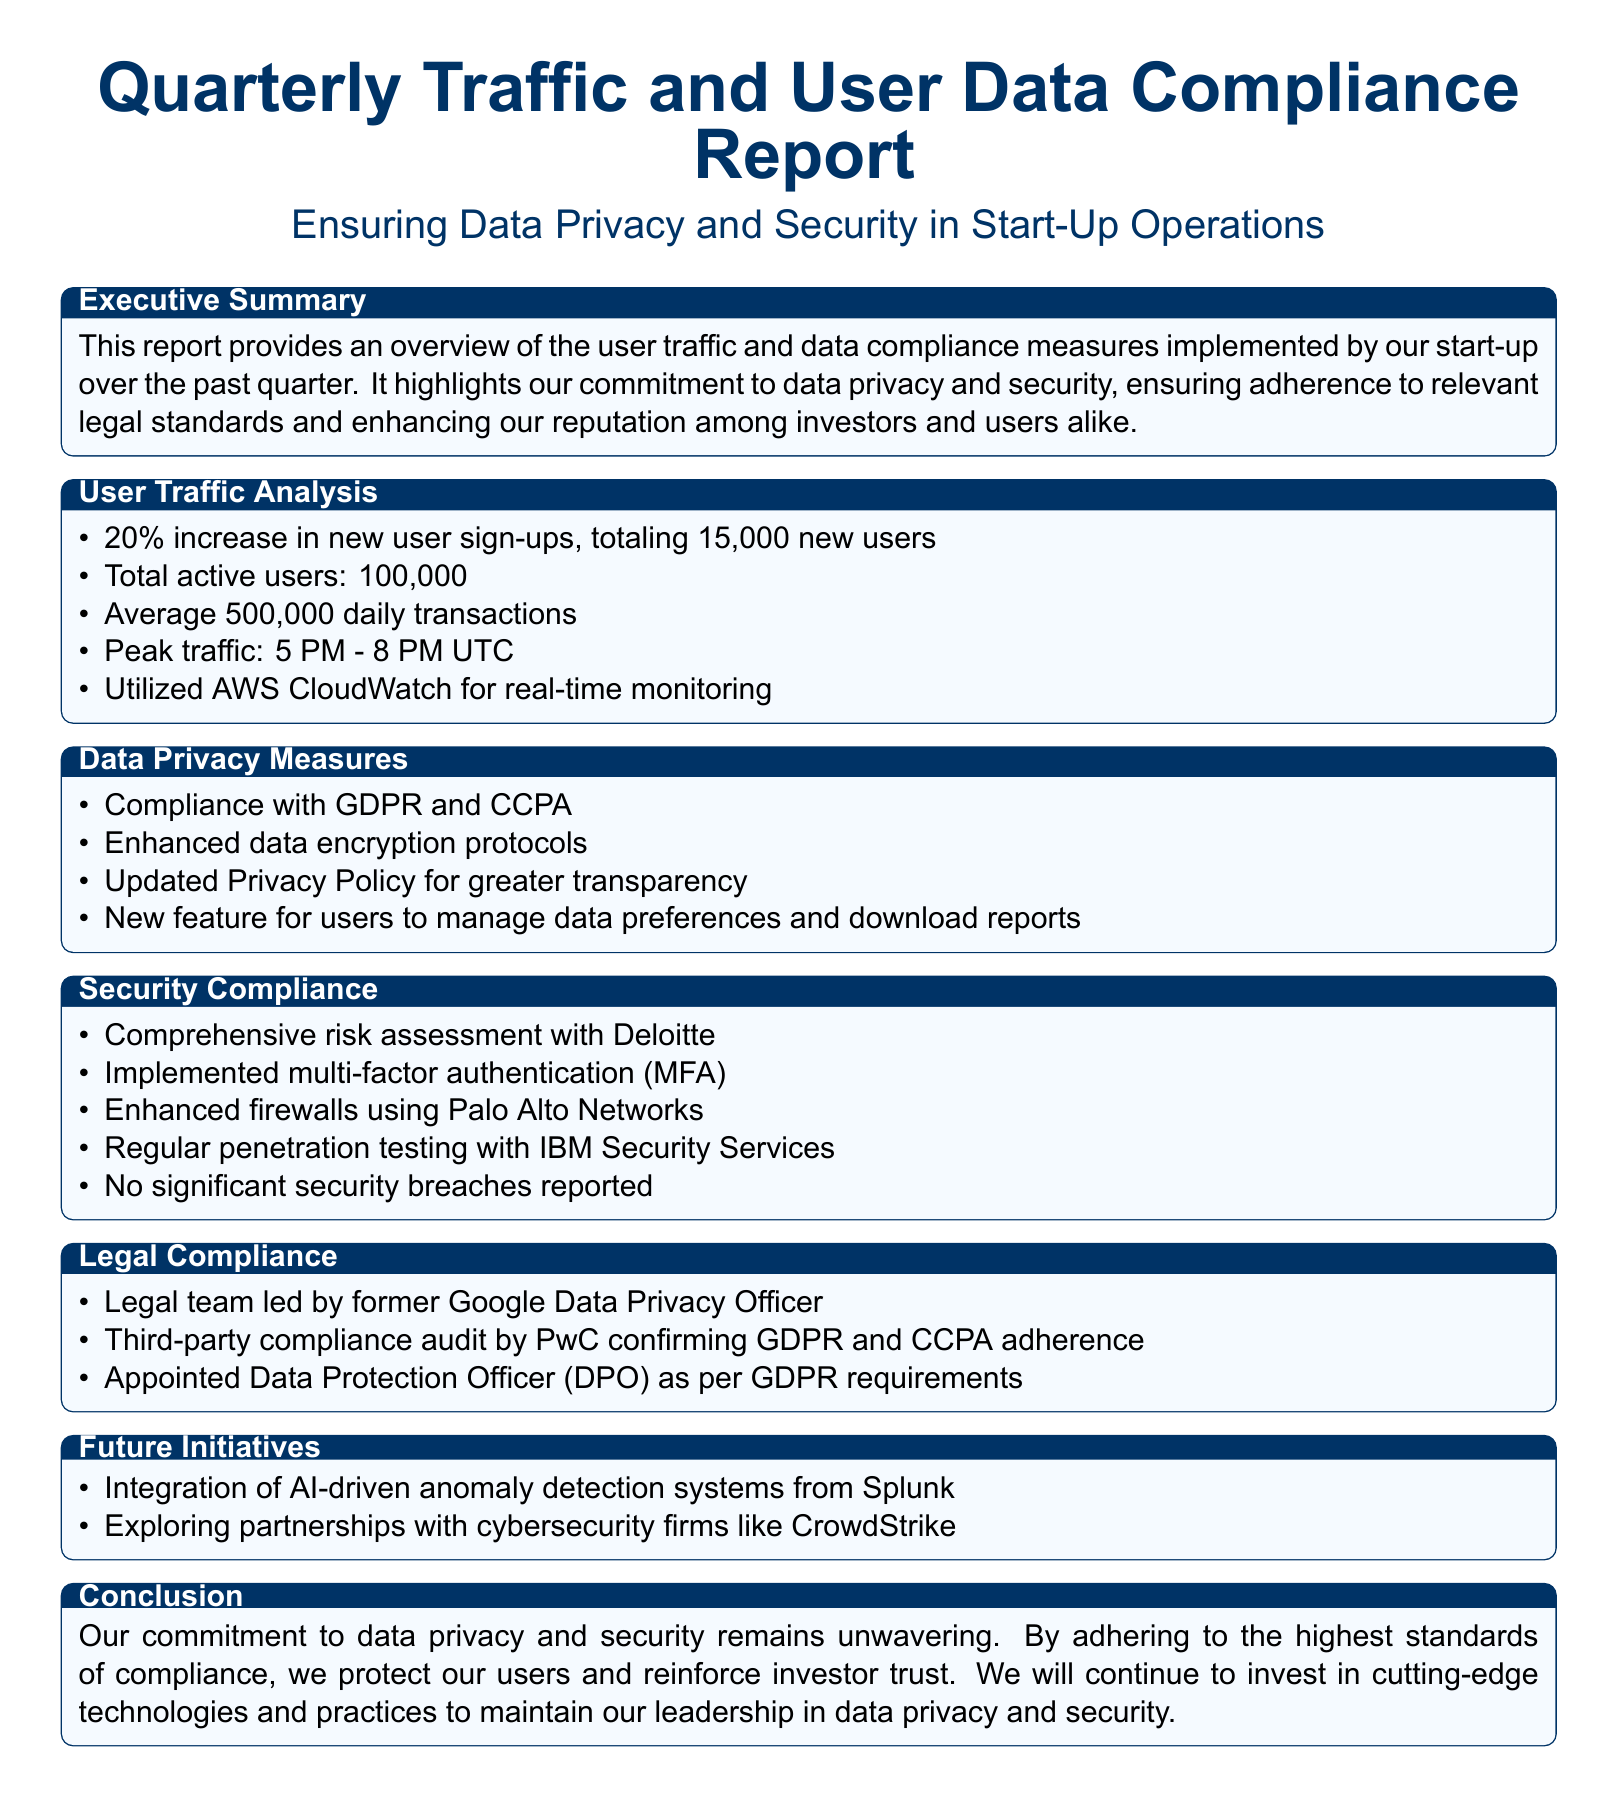What percentage increase in new user sign-ups was reported? The document states that there was a 20% increase in new user sign-ups, indicating growth in the user base.
Answer: 20% What is the total number of active users? The report mentions a total of 100,000 active users, reflecting the current user engagement level.
Answer: 100,000 Which data privacy regulations does the company comply with? The report lists GDPR and CCPA as the regulatory frameworks adhered to by the start-up, ensuring legal compliance.
Answer: GDPR and CCPA Who conducted the comprehensive risk assessment? The document identifies Deloitte as the firm responsible for performing the risk assessment, ensuring thorough evaluation of security measures.
Answer: Deloitte What feature was introduced for users regarding their data preferences? The report states that a new feature allows users to manage their data preferences and download reports, enhancing transparency.
Answer: Manage data preferences and download reports What significant security measure was recently implemented? The document highlights the introduction of multi-factor authentication (MFA) as a key security enhancement, bolstering user account safety.
Answer: Multi-factor authentication (MFA) Who leads the legal team in charge of compliance? The report mentions that the legal team is led by a former Google Data Privacy Officer, indicating leadership expertise in data privacy.
Answer: Former Google Data Privacy Officer What new technology integration is being explored for future initiatives? The document indicates an interest in AI-driven anomaly detection systems from Splunk, showing a forward-looking approach to security.
Answer: AI-driven anomaly detection systems from Splunk Was there any significant security breach reported? The report specifically notes that no significant security breaches were reported, indicating the effectiveness of current security measures.
Answer: No significant security breaches reported 